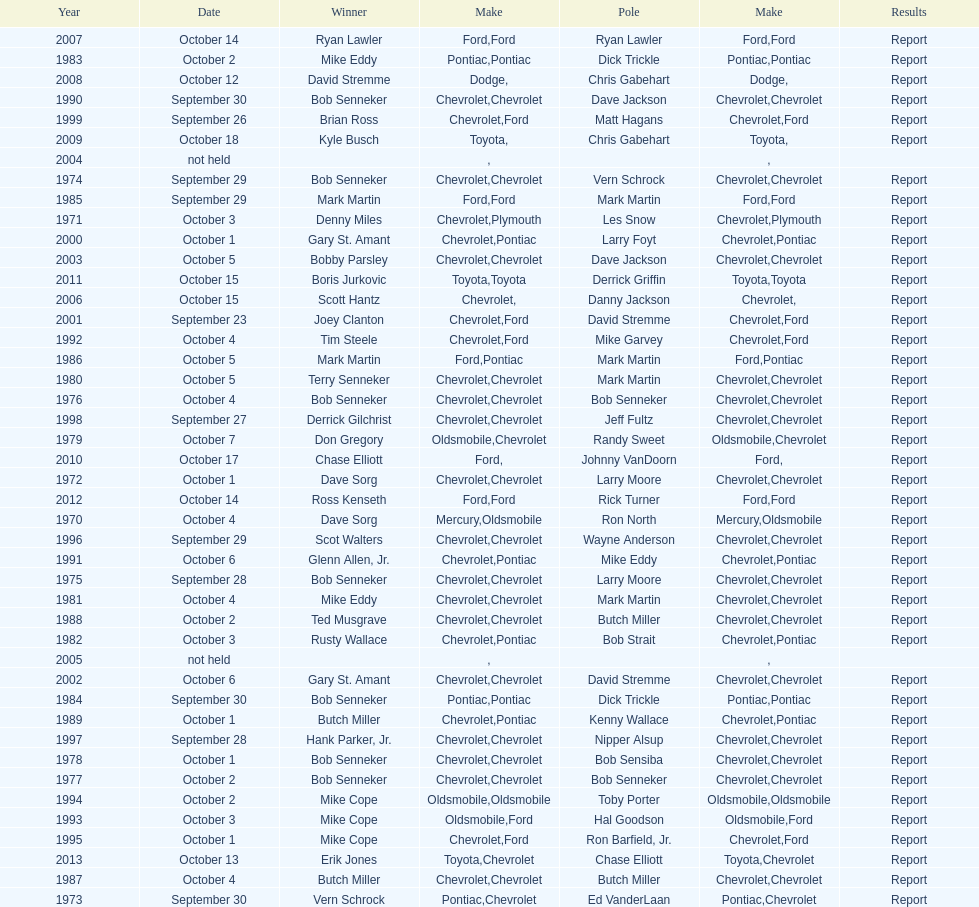How many winning oldsmobile vehicles made the list? 3. 